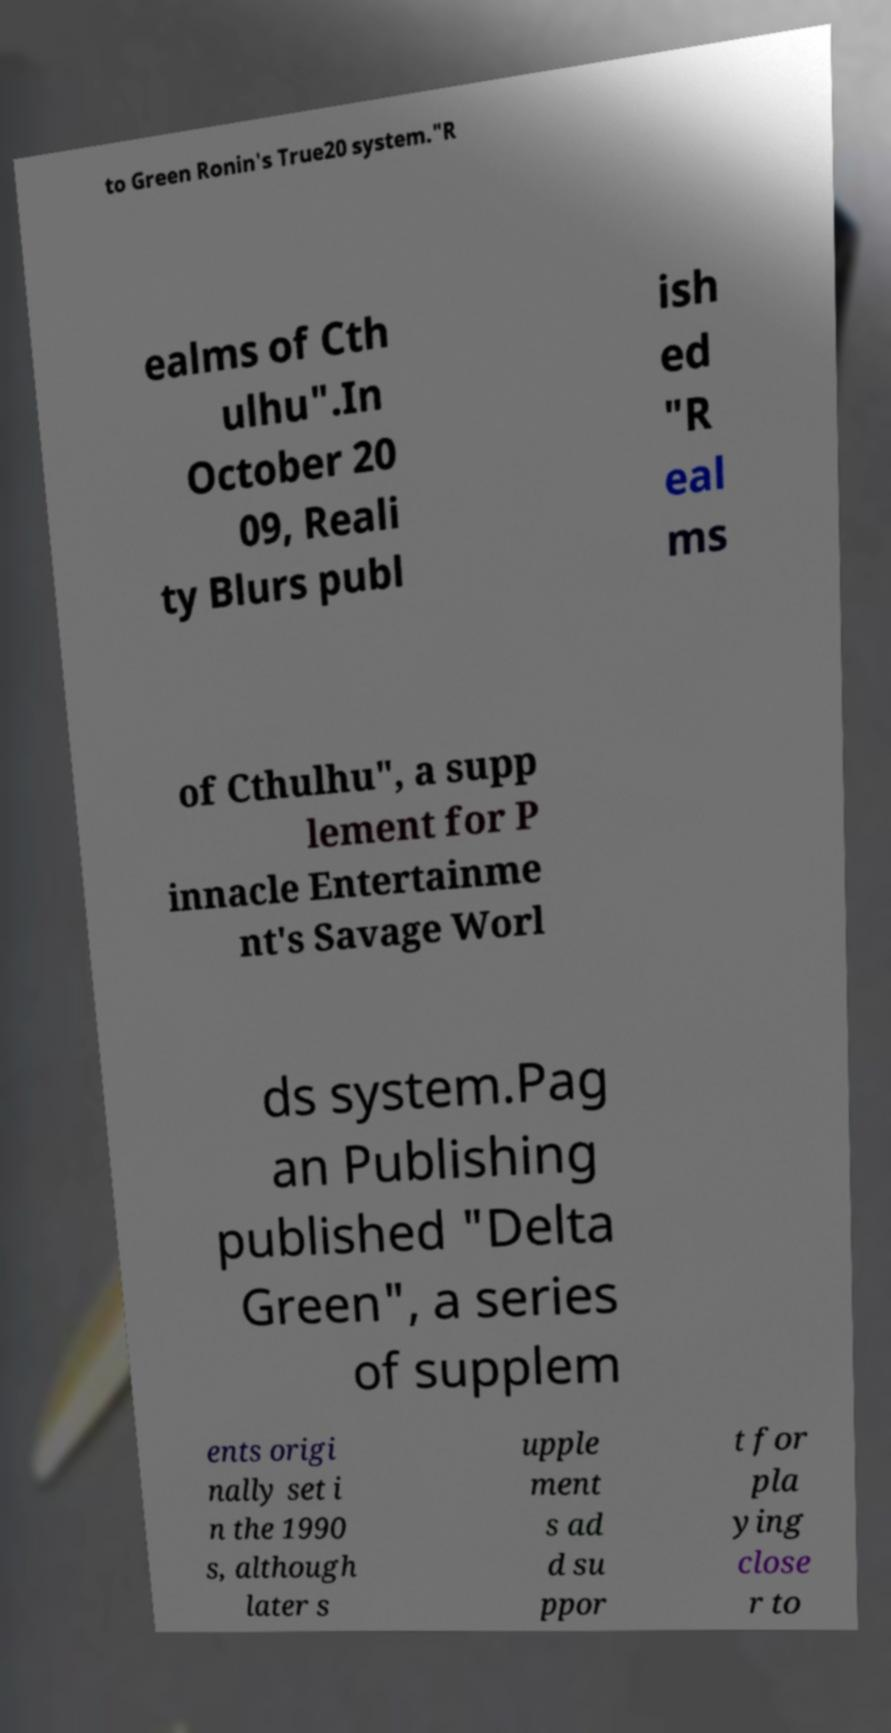Can you read and provide the text displayed in the image?This photo seems to have some interesting text. Can you extract and type it out for me? to Green Ronin's True20 system."R ealms of Cth ulhu".In October 20 09, Reali ty Blurs publ ish ed "R eal ms of Cthulhu", a supp lement for P innacle Entertainme nt's Savage Worl ds system.Pag an Publishing published "Delta Green", a series of supplem ents origi nally set i n the 1990 s, although later s upple ment s ad d su ppor t for pla ying close r to 